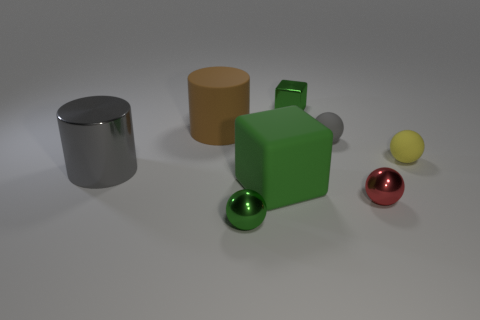There is a tiny metallic ball left of the tiny rubber sphere that is to the left of the small yellow object; what number of green shiny balls are in front of it?
Ensure brevity in your answer.  0. There is a small rubber ball behind the yellow ball that is in front of the small gray matte ball; what is its color?
Your answer should be very brief. Gray. How many other things are there of the same material as the yellow sphere?
Offer a terse response. 3. What number of tiny blocks are behind the cube behind the yellow object?
Provide a succinct answer. 0. Is there any other thing that is the same shape as the small gray object?
Your answer should be compact. Yes. Do the tiny metallic ball left of the gray ball and the block behind the big cube have the same color?
Provide a succinct answer. Yes. Are there fewer shiny cylinders than large cylinders?
Offer a terse response. Yes. The metallic object that is behind the yellow thing that is to the right of the rubber block is what shape?
Give a very brief answer. Cube. Is there any other thing that has the same size as the green rubber block?
Give a very brief answer. Yes. What is the shape of the gray shiny thing that is behind the small green object in front of the tiny gray object that is behind the tiny green metal ball?
Your response must be concise. Cylinder. 